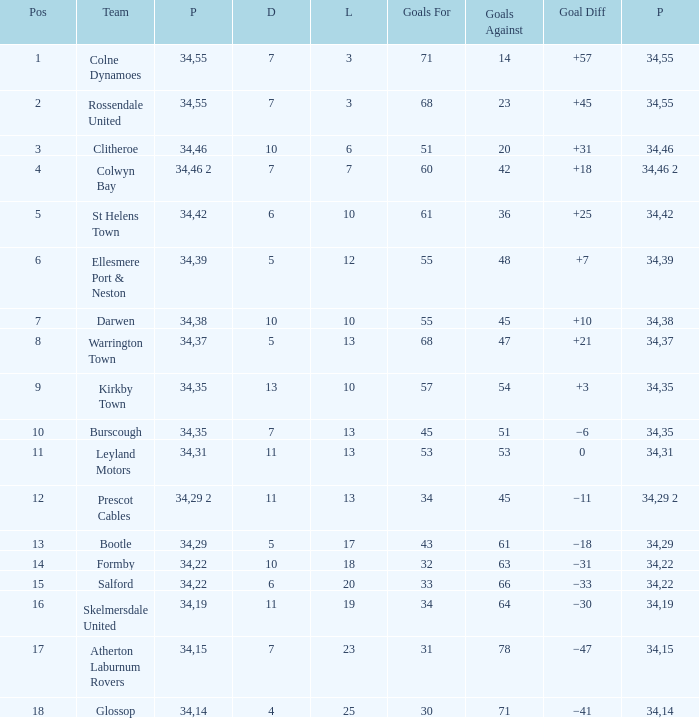Which Goals For has a Lost of 12, and a Played larger than 34? None. 